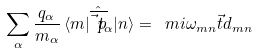Convert formula to latex. <formula><loc_0><loc_0><loc_500><loc_500>\sum _ { \alpha } \frac { q _ { \alpha } } { m _ { \alpha } } \, \langle m | \hat { \overline { \vec { t } { p } } } _ { \alpha } | n \rangle = \ m i \omega _ { m n } \vec { t } { d } _ { m n }</formula> 